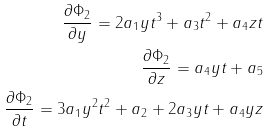<formula> <loc_0><loc_0><loc_500><loc_500>\frac { \partial \Phi _ { 2 } } { \partial y } = 2 a _ { 1 } y t ^ { 3 } + a _ { 3 } t ^ { 2 } + a _ { 4 } z t \\ \frac { \partial \Phi _ { 2 } } { \partial z } = a _ { 4 } y t + a _ { 5 } \\ \frac { \partial \Phi _ { 2 } } { \partial t } = 3 a _ { 1 } y ^ { 2 } t ^ { 2 } + a _ { 2 } + 2 a _ { 3 } y t + a _ { 4 } y z</formula> 